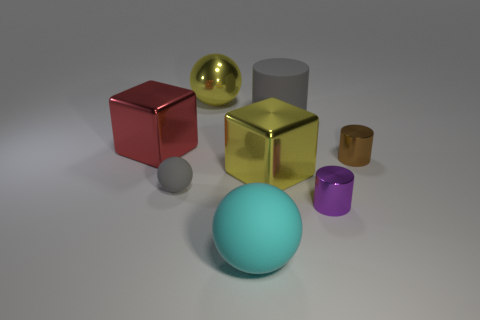Add 1 large red cylinders. How many objects exist? 9 Subtract all cylinders. How many objects are left? 5 Add 2 tiny purple cylinders. How many tiny purple cylinders exist? 3 Subtract 0 green spheres. How many objects are left? 8 Subtract all tiny red cylinders. Subtract all big cylinders. How many objects are left? 7 Add 4 metallic balls. How many metallic balls are left? 5 